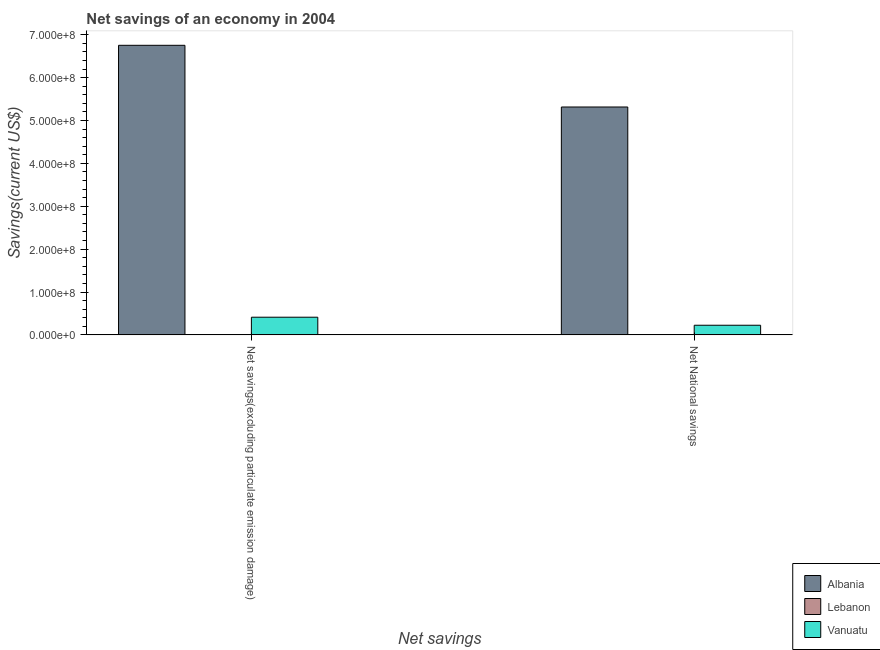Are the number of bars on each tick of the X-axis equal?
Make the answer very short. Yes. What is the label of the 2nd group of bars from the left?
Keep it short and to the point. Net National savings. Across all countries, what is the maximum net national savings?
Offer a very short reply. 5.31e+08. In which country was the net national savings maximum?
Keep it short and to the point. Albania. What is the total net savings(excluding particulate emission damage) in the graph?
Your answer should be compact. 7.16e+08. What is the difference between the net savings(excluding particulate emission damage) in Vanuatu and that in Albania?
Your answer should be compact. -6.34e+08. What is the difference between the net savings(excluding particulate emission damage) in Lebanon and the net national savings in Albania?
Offer a terse response. -5.31e+08. What is the average net national savings per country?
Keep it short and to the point. 1.85e+08. What is the difference between the net savings(excluding particulate emission damage) and net national savings in Vanuatu?
Keep it short and to the point. 1.87e+07. In how many countries, is the net national savings greater than 180000000 US$?
Offer a very short reply. 1. What is the ratio of the net national savings in Albania to that in Vanuatu?
Make the answer very short. 23.61. What is the difference between two consecutive major ticks on the Y-axis?
Keep it short and to the point. 1.00e+08. Does the graph contain any zero values?
Provide a short and direct response. Yes. How are the legend labels stacked?
Ensure brevity in your answer.  Vertical. What is the title of the graph?
Offer a terse response. Net savings of an economy in 2004. What is the label or title of the X-axis?
Offer a very short reply. Net savings. What is the label or title of the Y-axis?
Ensure brevity in your answer.  Savings(current US$). What is the Savings(current US$) of Albania in Net savings(excluding particulate emission damage)?
Your answer should be compact. 6.75e+08. What is the Savings(current US$) in Lebanon in Net savings(excluding particulate emission damage)?
Your response must be concise. 0. What is the Savings(current US$) in Vanuatu in Net savings(excluding particulate emission damage)?
Your answer should be compact. 4.12e+07. What is the Savings(current US$) in Albania in Net National savings?
Provide a succinct answer. 5.31e+08. What is the Savings(current US$) of Vanuatu in Net National savings?
Provide a short and direct response. 2.25e+07. Across all Net savings, what is the maximum Savings(current US$) of Albania?
Offer a very short reply. 6.75e+08. Across all Net savings, what is the maximum Savings(current US$) of Vanuatu?
Your answer should be very brief. 4.12e+07. Across all Net savings, what is the minimum Savings(current US$) of Albania?
Provide a short and direct response. 5.31e+08. Across all Net savings, what is the minimum Savings(current US$) in Vanuatu?
Provide a short and direct response. 2.25e+07. What is the total Savings(current US$) in Albania in the graph?
Your response must be concise. 1.21e+09. What is the total Savings(current US$) of Lebanon in the graph?
Offer a very short reply. 0. What is the total Savings(current US$) of Vanuatu in the graph?
Keep it short and to the point. 6.37e+07. What is the difference between the Savings(current US$) of Albania in Net savings(excluding particulate emission damage) and that in Net National savings?
Offer a very short reply. 1.44e+08. What is the difference between the Savings(current US$) of Vanuatu in Net savings(excluding particulate emission damage) and that in Net National savings?
Your answer should be very brief. 1.87e+07. What is the difference between the Savings(current US$) in Albania in Net savings(excluding particulate emission damage) and the Savings(current US$) in Vanuatu in Net National savings?
Keep it short and to the point. 6.53e+08. What is the average Savings(current US$) in Albania per Net savings?
Keep it short and to the point. 6.03e+08. What is the average Savings(current US$) of Lebanon per Net savings?
Provide a succinct answer. 0. What is the average Savings(current US$) of Vanuatu per Net savings?
Your answer should be very brief. 3.19e+07. What is the difference between the Savings(current US$) of Albania and Savings(current US$) of Vanuatu in Net savings(excluding particulate emission damage)?
Ensure brevity in your answer.  6.34e+08. What is the difference between the Savings(current US$) of Albania and Savings(current US$) of Vanuatu in Net National savings?
Offer a very short reply. 5.09e+08. What is the ratio of the Savings(current US$) of Albania in Net savings(excluding particulate emission damage) to that in Net National savings?
Offer a very short reply. 1.27. What is the ratio of the Savings(current US$) in Vanuatu in Net savings(excluding particulate emission damage) to that in Net National savings?
Make the answer very short. 1.83. What is the difference between the highest and the second highest Savings(current US$) in Albania?
Offer a terse response. 1.44e+08. What is the difference between the highest and the second highest Savings(current US$) in Vanuatu?
Your response must be concise. 1.87e+07. What is the difference between the highest and the lowest Savings(current US$) in Albania?
Offer a terse response. 1.44e+08. What is the difference between the highest and the lowest Savings(current US$) in Vanuatu?
Offer a very short reply. 1.87e+07. 